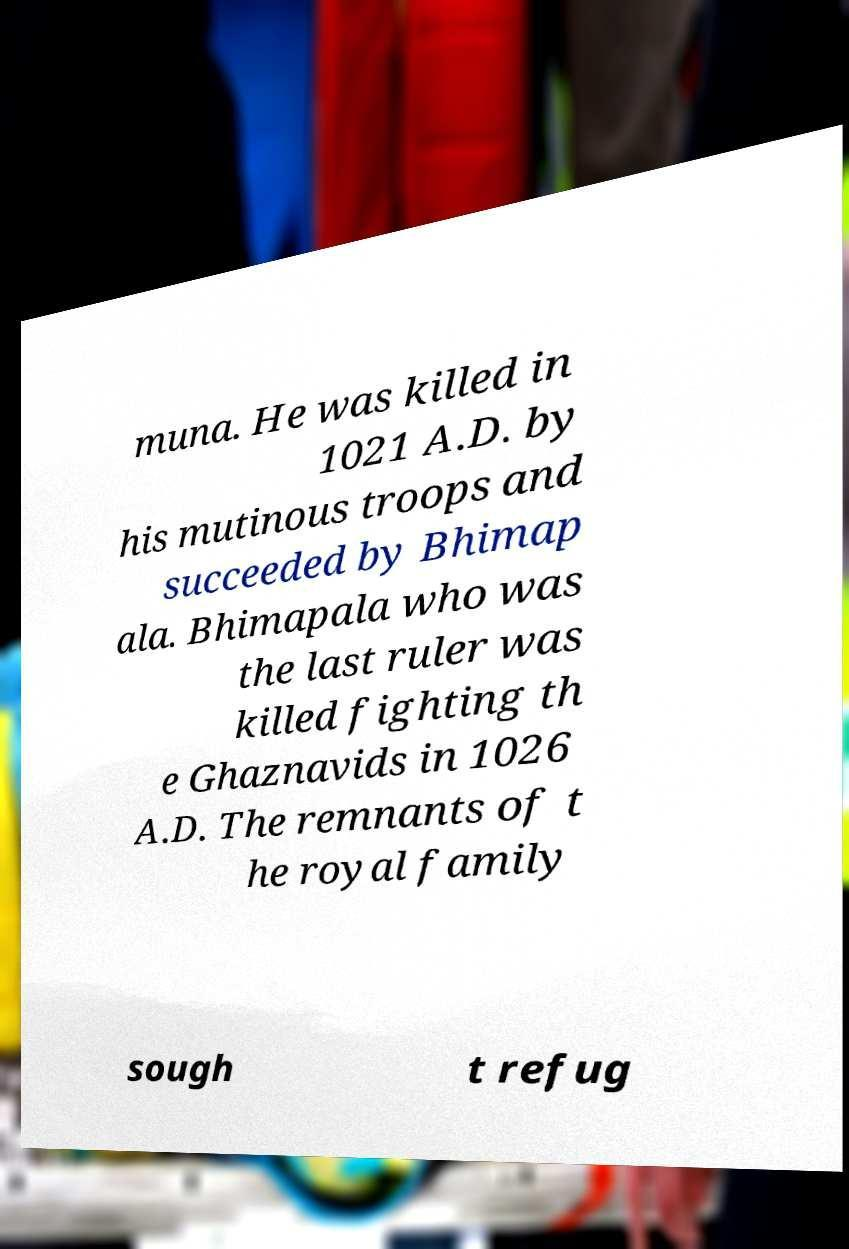Can you accurately transcribe the text from the provided image for me? muna. He was killed in 1021 A.D. by his mutinous troops and succeeded by Bhimap ala. Bhimapala who was the last ruler was killed fighting th e Ghaznavids in 1026 A.D. The remnants of t he royal family sough t refug 